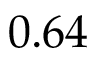<formula> <loc_0><loc_0><loc_500><loc_500>0 . 6 4</formula> 